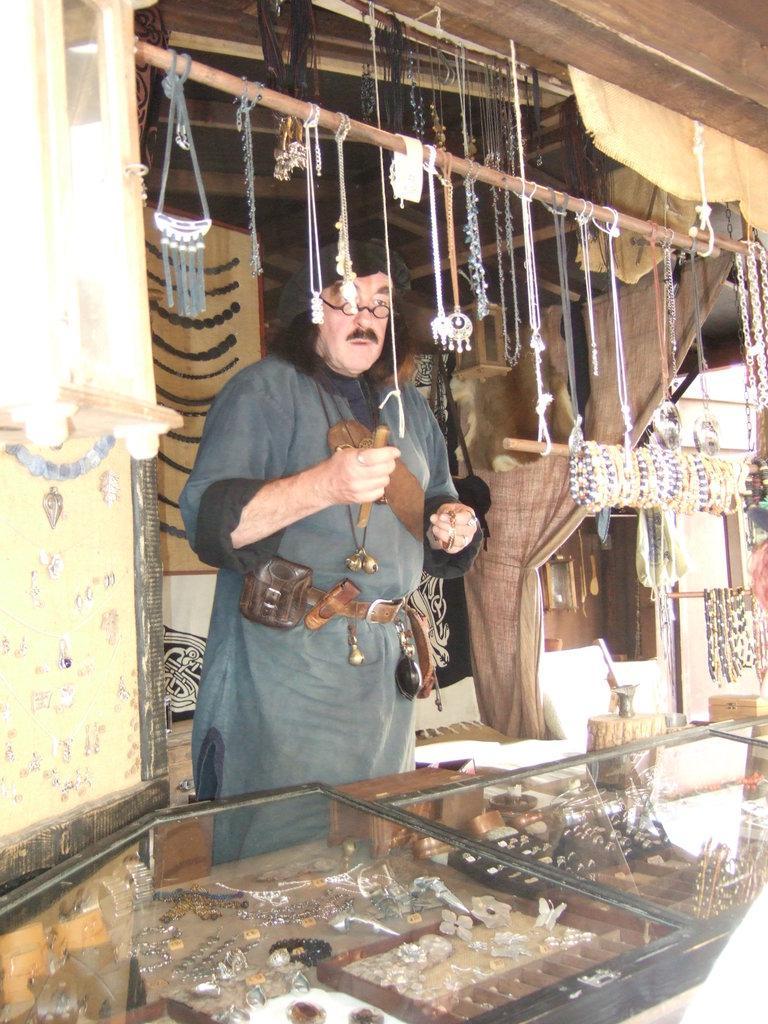Describe this image in one or two sentences. In this image I can see a man is standing and holding some object in the hand. Here I can see a glass table. In the table I can see some objects. I can also see some objects hanging to a stick. 